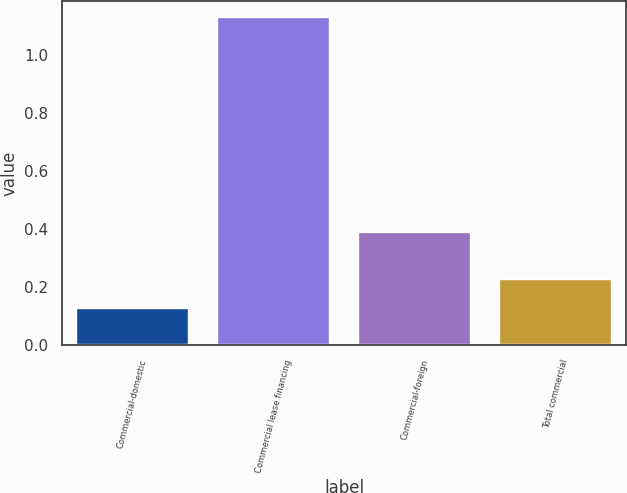Convert chart to OTSL. <chart><loc_0><loc_0><loc_500><loc_500><bar_chart><fcel>Commercial-domestic<fcel>Commercial lease financing<fcel>Commercial-foreign<fcel>Total commercial<nl><fcel>0.13<fcel>1.13<fcel>0.39<fcel>0.23<nl></chart> 